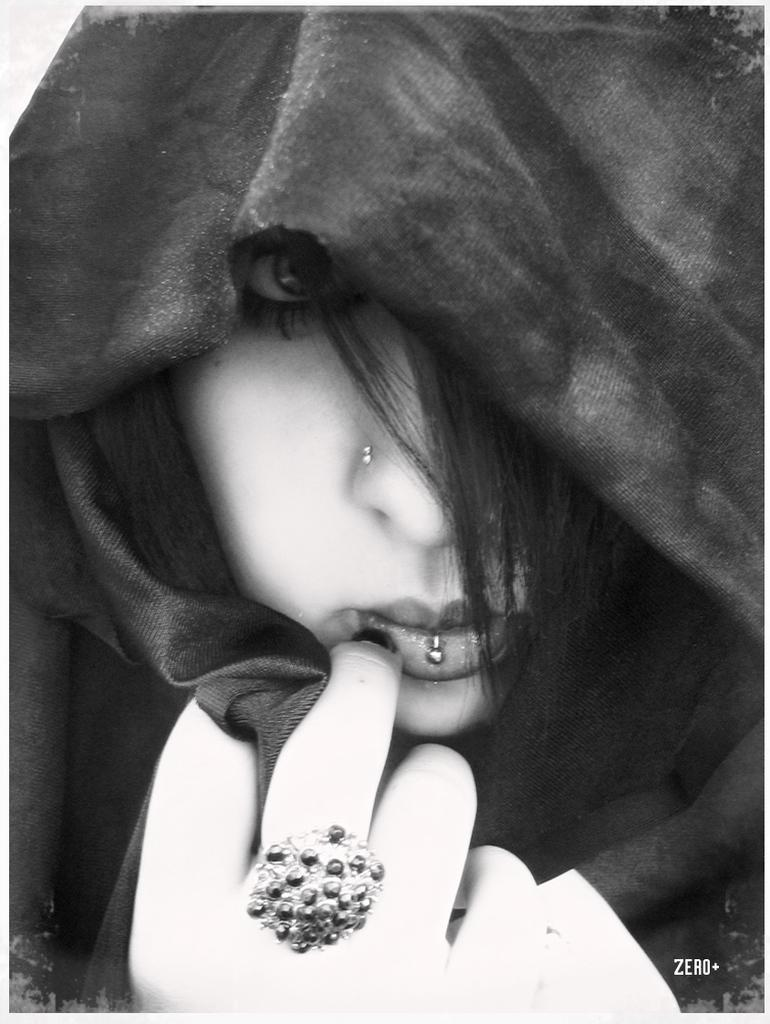Who is present in the image? There is a woman in the image. What is the woman wearing around her neck? The woman is wearing a scarf. What type of jewelry can be seen on the woman's hand? The woman has a ring on her hand. Where is the text located in the image? The text is in the bottom right corner of the image. What type of glass is the scarecrow holding in the image? There is no scarecrow or glass present in the image. 